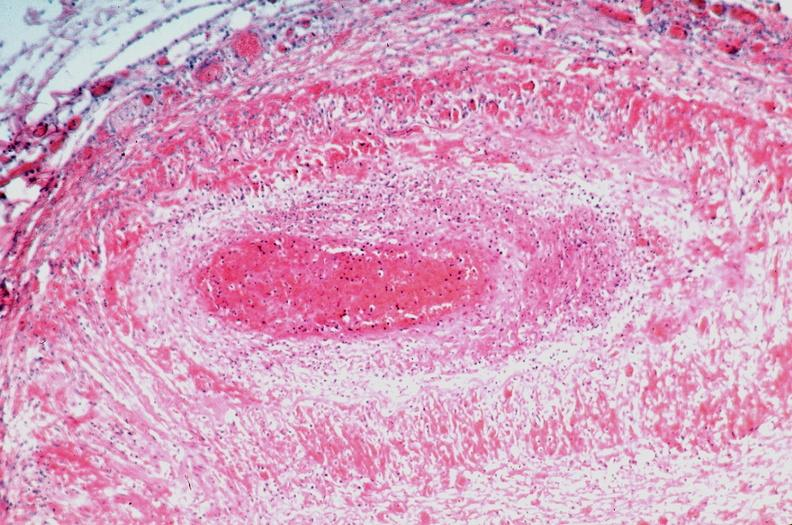s cardiovascular present?
Answer the question using a single word or phrase. Yes 